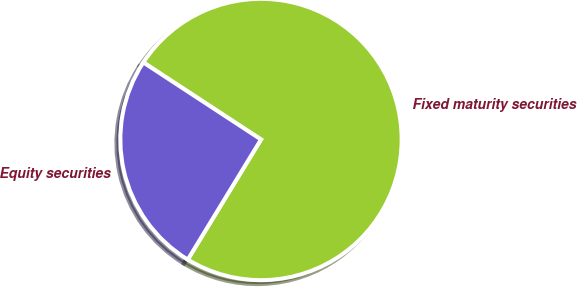Convert chart. <chart><loc_0><loc_0><loc_500><loc_500><pie_chart><fcel>Fixed maturity securities<fcel>Equity securities<nl><fcel>74.49%<fcel>25.51%<nl></chart> 